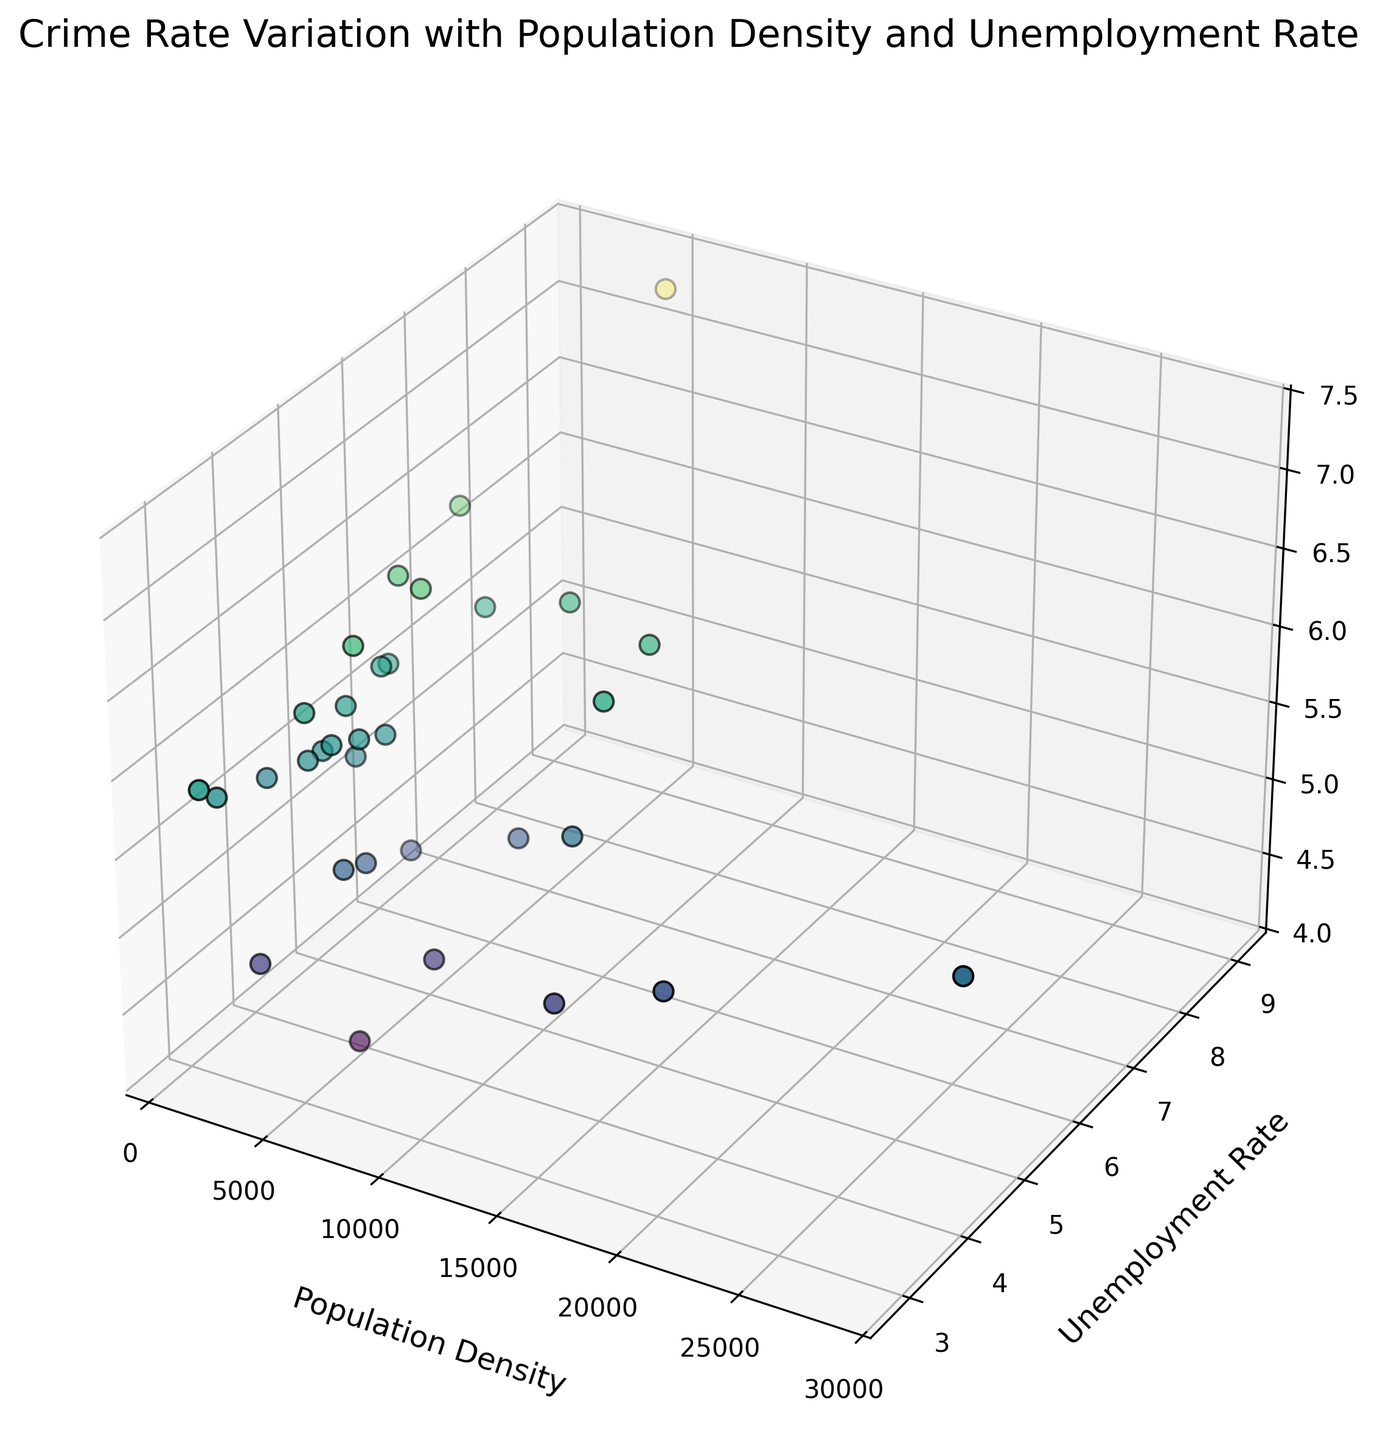What is the trend observed between Population Density and Crime Rate for cities with low Unemployment Rates (less than 4%)? Look for the data points representing cities with low Unemployment Rates (less than 4%) and observe the trend between Population Density and Crime Rate. Most cities with low Unemployment Rates appear to be scattered across different levels of Population Density.
Answer: No clear trend, varies Which city has the highest Crime Rate, and what are its Population Density and Unemployment Rate? Identify the highest point on the Crime Rate axis. The city with the highest Crime Rate is Detroit. Its Population Density is 4970, and its Unemployment Rate is 9.1%.
Answer: Detroit; Population Density: 4970; Unemployment Rate: 9.1% Does a higher Unemployment Rate generally correspond to a higher Crime Rate? Check for cities with high Unemployment Rates and compare their Crime Rates. Cities like Detroit and Memphis show this trend, while others like Los Angeles or Seattle do not.
Answer: Mixed correlation What is the general pattern of Crime Rate concerning Population Density for cities with high Unemployment Rates (greater than 6%)? Focus on the data points representing cities with high Unemployment Rates (greater than 6%) and analyze the spread of their Crime Rates relative to Population Density. Higher Unemployment Rates do not show a consistent pattern with Crime Rates; it varies widely across different Population Densities.
Answer: No consistent pattern Which city has the lowest Crime Rate, and what are its Population Density and Unemployment Rate? Identify the lowest point on the Crime Rate axis. San Jose has the lowest Crime Rate, with a Population Density of 5762 and an Unemployment Rate of 3.6%.
Answer: San Jose; Population Density: 5762; Unemployment Rate: 3.6% Among cities with similar Population Density (4000 to 5000), which city has the highest Crime Rate, and what is its Unemployment Rate? Locate data points within the Population Density range of 4000 to 5000. The city with the highest Crime Rate in this range is Houston, with an Unemployment Rate of 5.5%.
Answer: Houston; Unemployment Rate: 5.5% Is there a city with a high Population Density (greater than 10000) and a low Crime Rate? Look for data points with Population Density greater than 10000 and observe their Crime Rates. Washington has a high Population Density (11870) and a relatively low Crime Rate (5.4) compared to others like Chicago.
Answer: Washington Do cities with Population Density between 3000 and 4000 show similar Crime Rates? Examine the data points with Population Density between 3000 and 4000 and analyze their Crime Rates. These cities show varying Crime Rates, e.g., Fort Worth (5.7), San Diego (4.9), and Columbus (5.8).
Answer: No How does the Crime Rate in Seattle compare to that in Phoenix? Compare the data points for Seattle and Phoenix. Seattle has a Crime Rate of 4.7, while Phoenix has a Crime Rate of 6.3. Therefore, Seattle has a lower Crime Rate compared to Phoenix.
Answer: Seattle's Crime Rate is lower than Phoenix's What is the relationship between Unemployment Rate and Crime Rate in cities with medium Population Density (5000-10000)? Examine the data points with medium Population Density (5000-10000) and analyze the relationship between their Unemployment Rates and Crime Rates. Cities with medium Population Density show varied relationships; for instance, Seattle has a low Crime Rate with 4.0% Unemployment, while Baltimore has a higher Crime Rate with 6.4% Unemployment.
Answer: Varied relationship 